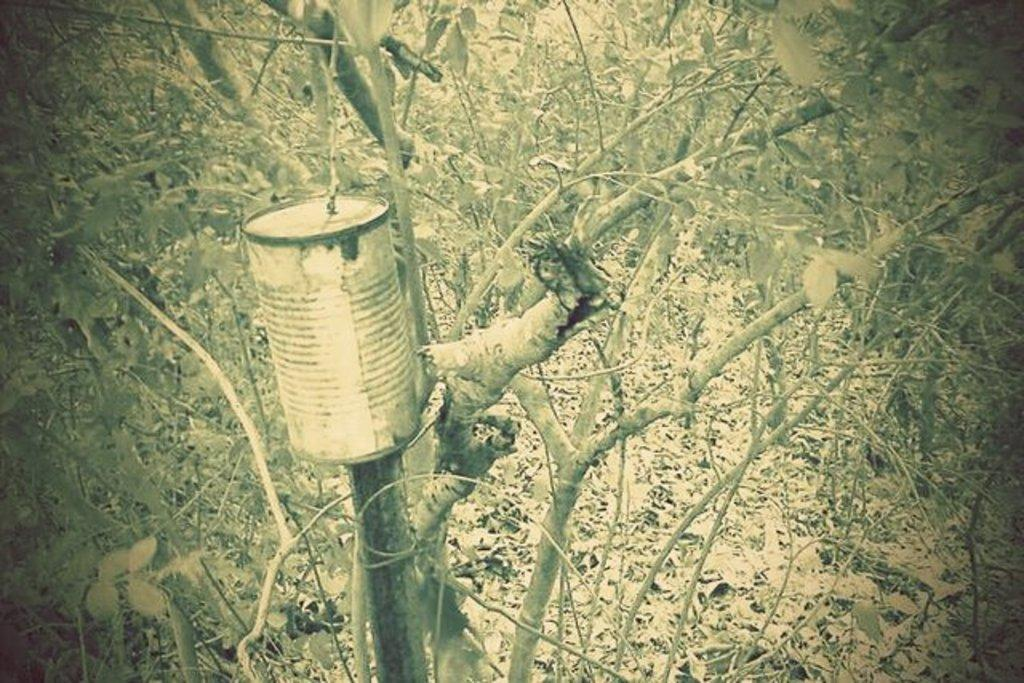What object can be seen in the image that is typically used for storage or packaging? There is a box in the image. What type of natural vegetation is visible in the image? There are trees in the image. What can be found on the ground in the image, indicating the presence of trees? Leaves are present on the ground in the image. What type of potato is being used to control the mind in the image? There is no potato or mention of controlling minds in the image; it features a box and trees. How many spiders are visible on the box in the image? There are no spiders present on the box in the image. 